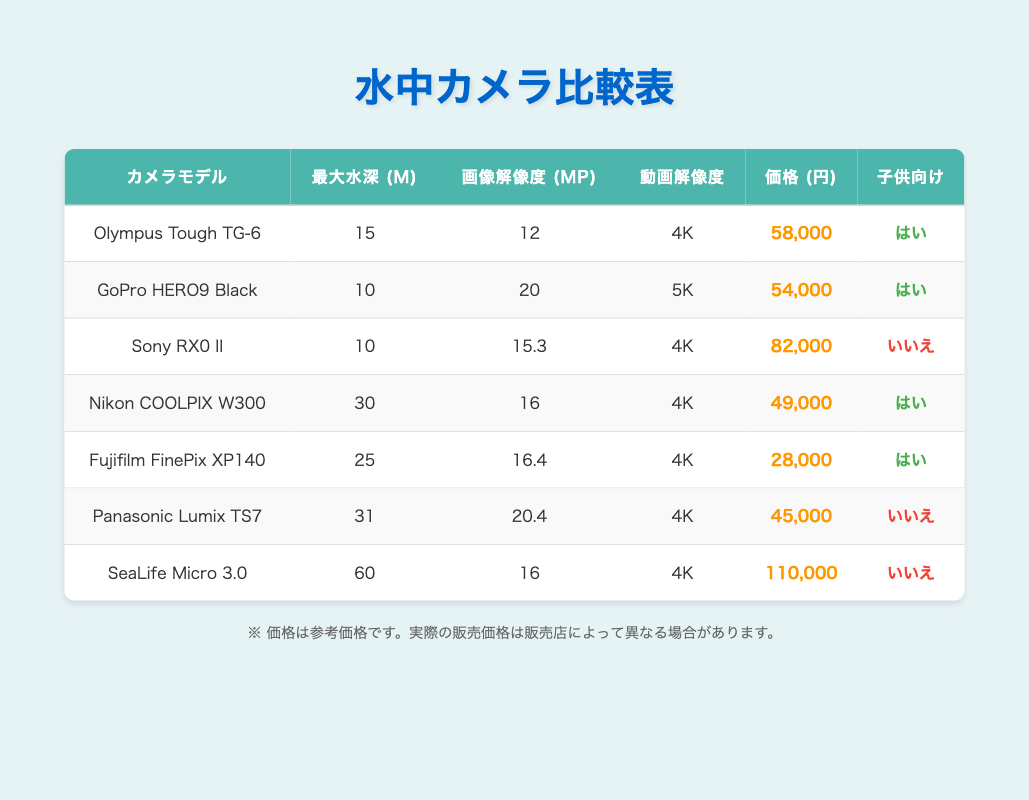What is the maximum depth for the Olympus Tough TG-6? The table shows that the maximum depth for the Olympus Tough TG-6 is listed as "15 m". Therefore, this is the answer.
Answer: 15 m Which cameras have a video resolution of 4K? By examining the table, the cameras with a video resolution of 4K are the Olympus Tough TG-6, Sony RX0 II, Nikon COOLPIX W300, Fujifilm FinePix XP140, Panasonic Lumix TS7, and SeaLife Micro 3.0.
Answer: Olympus Tough TG-6, Sony RX0 II, Nikon COOLPIX W300, Fujifilm FinePix XP140, Panasonic Lumix TS7, SeaLife Micro 3.0 What is the price difference between the most expensive and the least expensive camera? The most expensive camera is the SeaLife Micro 3.0, priced at ¥110,000, and the least expensive is the Fujifilm FinePix XP140 at ¥28,000. The price difference is calculated as ¥110,000 - ¥28,000 = ¥82,000.
Answer: ¥82,000 Are all the cameras suitable for children? Checking the table, the cameras that are suitable for children are the Olympus Tough TG-6, GoPro HERO9 Black, Nikon COOLPIX W300, and Fujifilm FinePix XP140. The Sony RX0 II, Panasonic Lumix TS7, and SeaLife Micro 3.0 are not suitable. Thus, not all cameras are suitable for children.
Answer: No What is the average image resolution of the cameras that are suitable for children? The cameras that are suitable for children and their image resolutions are: Olympus Tough TG-6 (12 MP), GoPro HERO9 Black (20 MP), Nikon COOLPIX W300 (16 MP), and Fujifilm FinePix XP140 (16.4 MP). To find the average: (12 + 20 + 16 + 16.4) / 4 = 64.4 / 4 = 16.1 MP.
Answer: 16.1 MP 